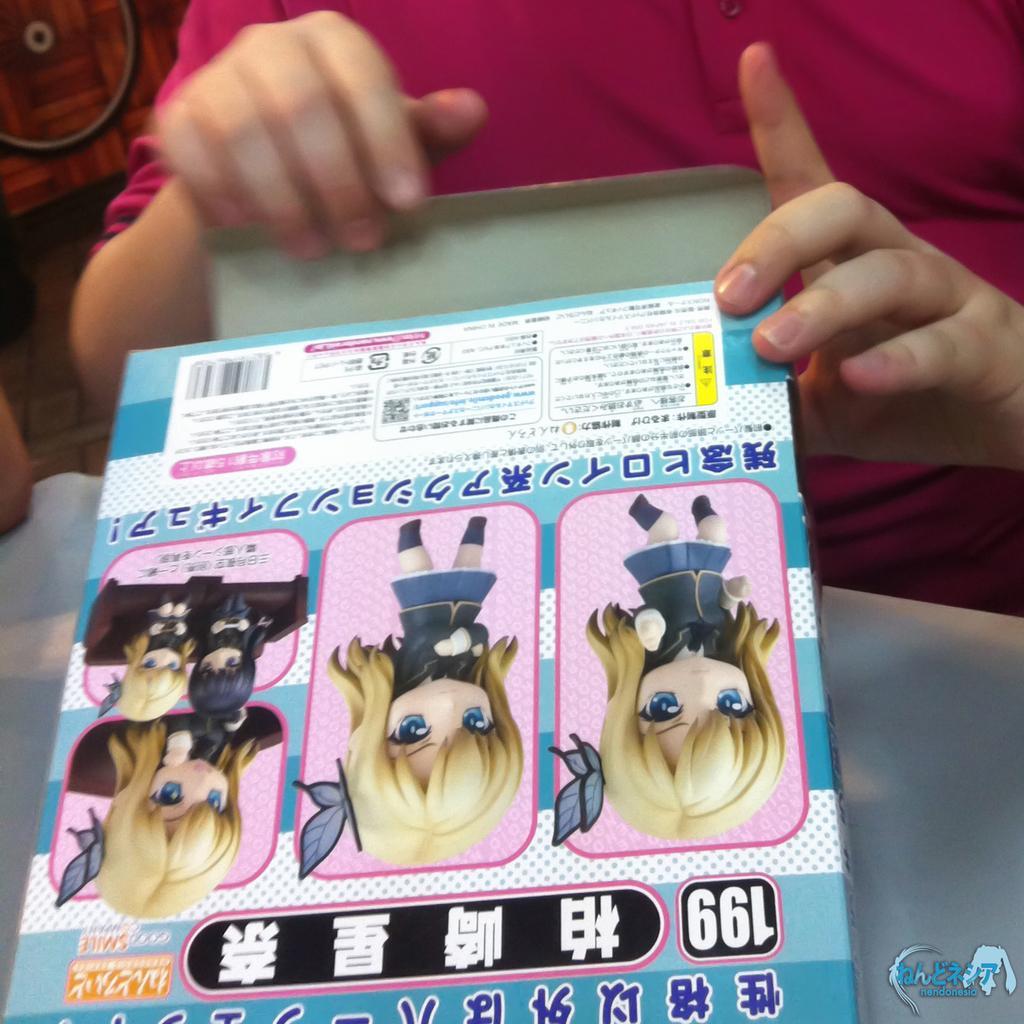Can you describe this image briefly? In this image there is a person, opening the toy box. 